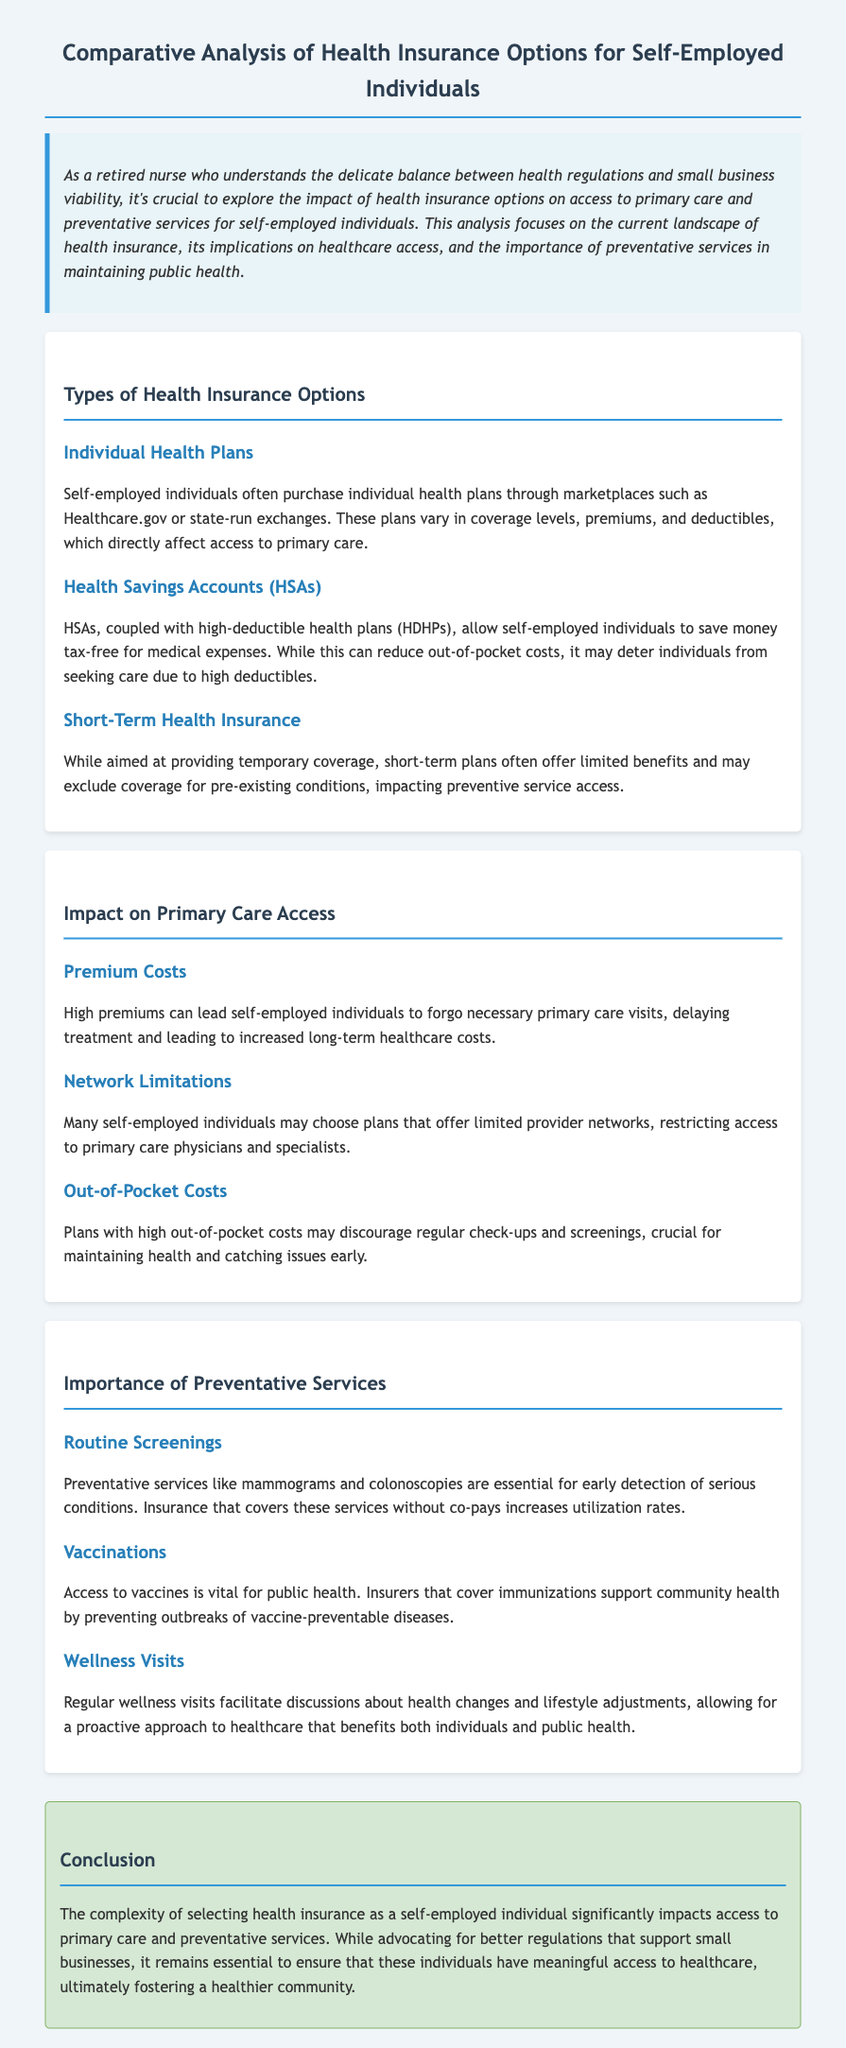what are the types of health insurance options mentioned? The document lists various health insurance options including Individual Health Plans, Health Savings Accounts (HSAs), and Short-Term Health Insurance.
Answer: Individual Health Plans, Health Savings Accounts (HSAs), Short-Term Health Insurance what impact do high premiums have on self-employed individuals? The document states that high premiums can lead individuals to forgo necessary primary care visits.
Answer: forgo necessary primary care visits which preventive service is mentioned as essential for early detection? The document highlights that routine screenings are essential for early detection of serious conditions.
Answer: Routine Screenings what does HSA stand for? The document refers to HSAs as Health Savings Accounts.
Answer: Health Savings Accounts how do high out-of-pocket costs affect healthcare behavior? The document states that high out-of-pocket costs may discourage regular check-ups and screenings.
Answer: discourage regular check-ups and screenings what is emphasized as vital for public health in relation to vaccinations? The document mentions that access to vaccines is vital for preventing outbreaks of vaccine-preventable diseases.
Answer: preventing outbreaks of vaccine-preventable diseases what is the main conclusion of the analysis? The analysis concludes that the complexity of health insurance selection significantly impacts access to primary care and preventative services.
Answer: impacts access to primary care and preventative services why are wellness visits important? The document states that regular wellness visits facilitate discussions about health changes and lifestyle adjustments.
Answer: facilitate discussions about health changes and lifestyle adjustments 